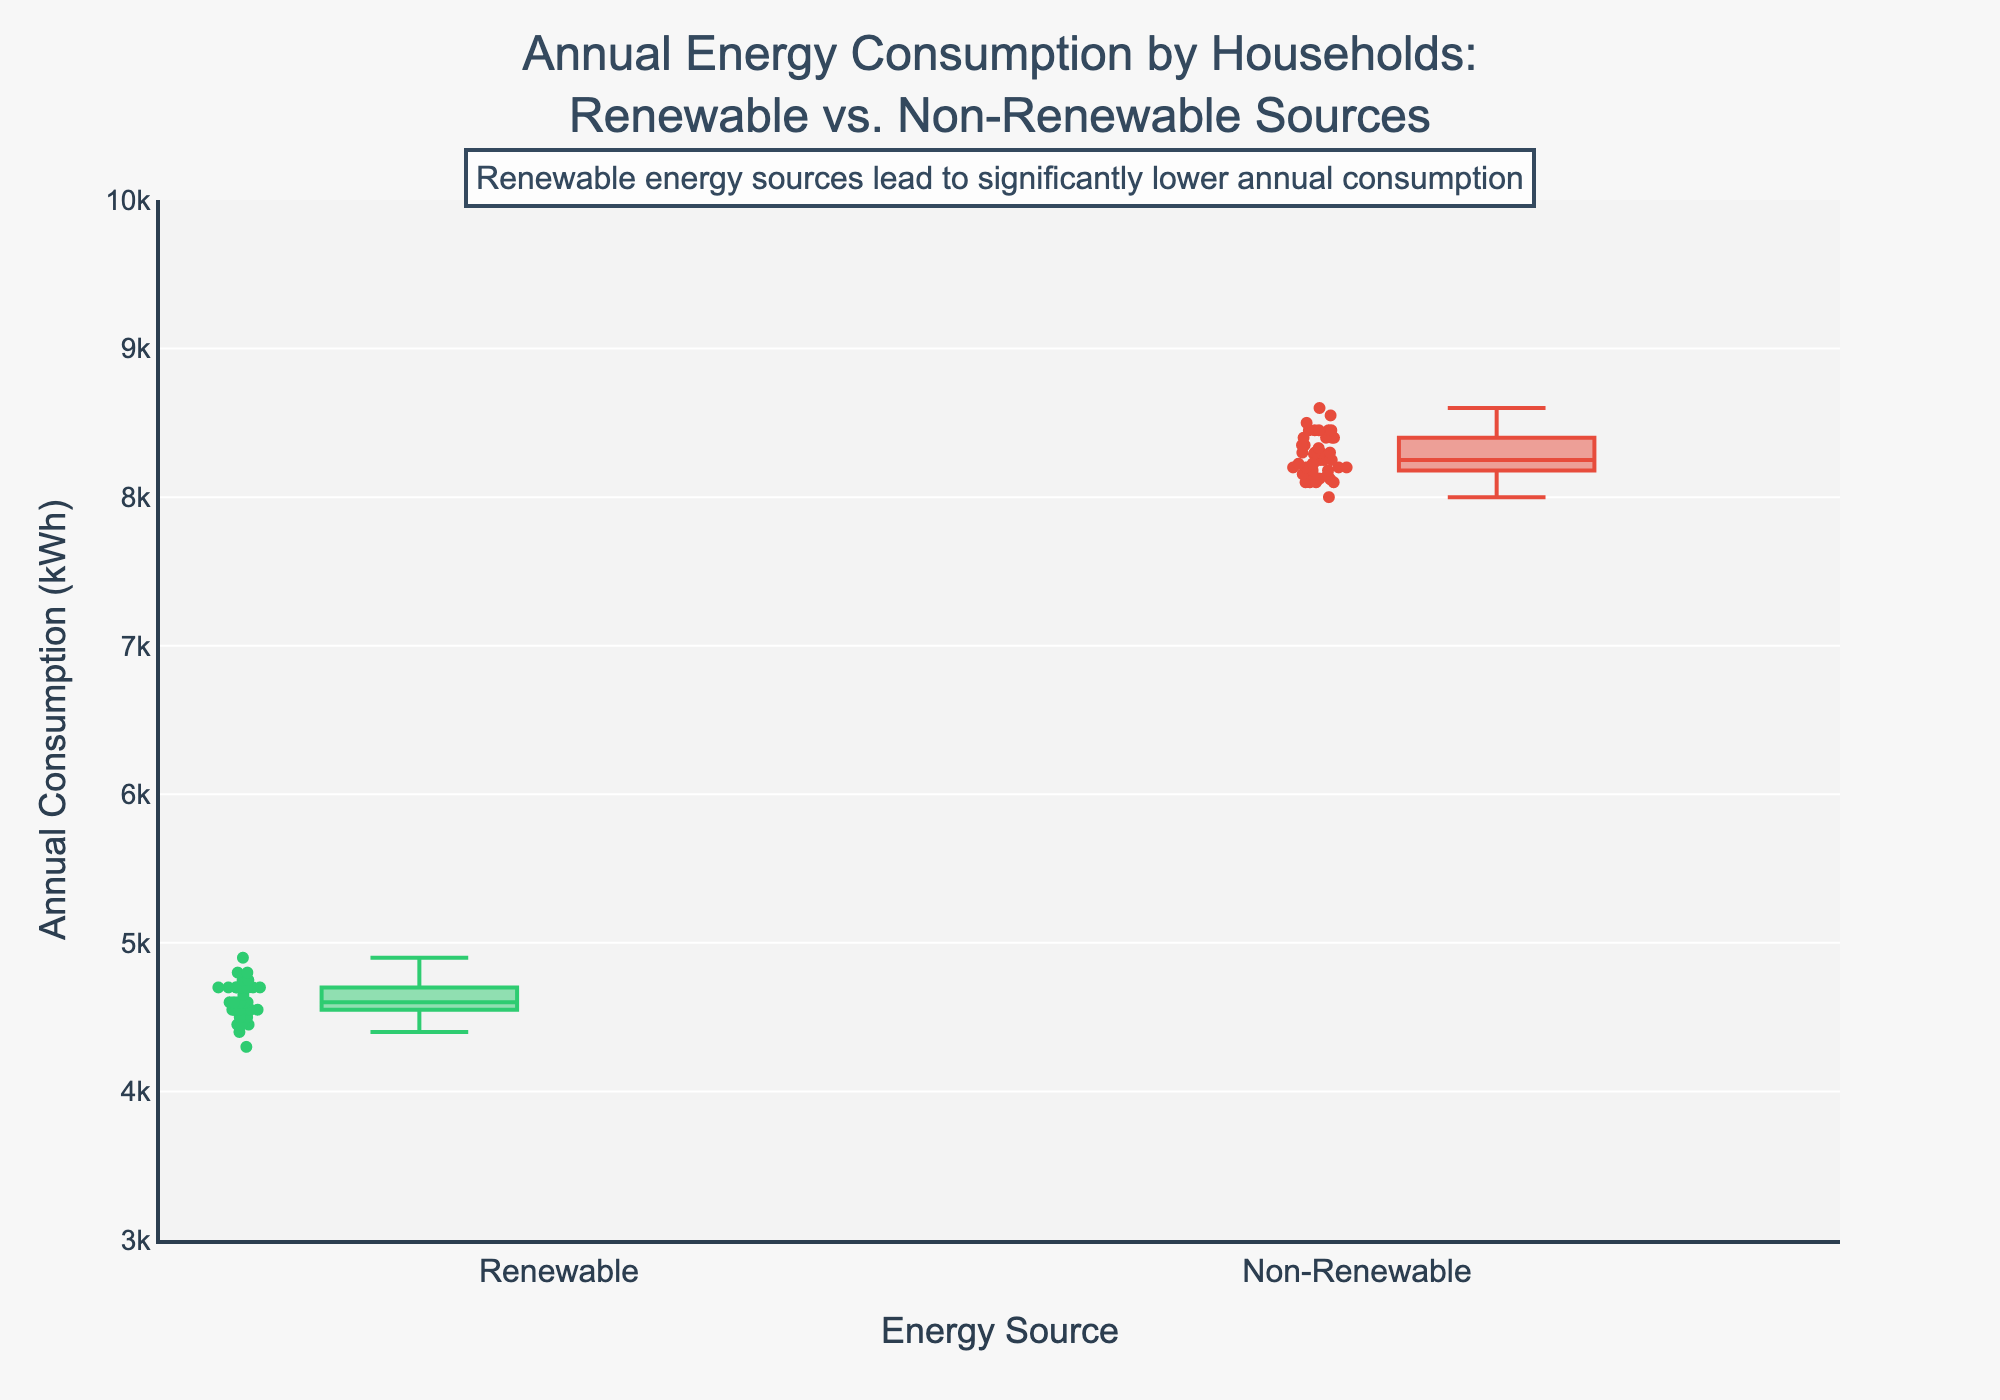What is the title of the figure? The title is prominently displayed at the top center of the figure. It reads "Annual Energy Consumption by Households: Renewable vs. Non-Renewable Sources".
Answer: Annual Energy Consumption by Households: Renewable vs. Non-Renewable Sources What are the colors representing each energy source? The colors used for the different groups are clearly shown in the box plot. Renewable energy sources are represented by green, and non-renewable energy sources are reflected in red.
Answer: Green for renewable and red for non-renewable What is the y-axis title? The y-axis title is placed vertically along the left side of the plot, and it reads "Annual Consumption (kWh)".
Answer: Annual Consumption (kWh) Which group has a higher median annual consumption? The median annual consumption for each group is indicated by the line inside each box. The non-renewable group has a higher median value compared to the renewable group.
Answer: Non-renewable What is the range of the y-axis? The y-axis range can be observed from the axis labels, which go from 3000 to 10000 kWh.
Answer: 3000 to 10000 kWh What is the general trend indicated by the annotation in the figure? The annotation at the top of the plot mentions that renewable energy sources lead to significantly lower annual consumption, suggesting a general trend of higher efficiency or lower usage with renewable sources.
Answer: Renewable energy sources lead to significantly lower annual consumption How does the interquartile range (IQR) of renewable energy compare to non-renewable energy? The IQR is the range between the first quartile (Q1) and the third quartile (Q3) of the data. By examining the height of the boxes in the plot, the IQR for renewable energy is smaller compared to non-renewable energy, indicating less variability.
Answer: Smaller IQR for renewable energy What is the approximate maximum value for the non-renewable energy group? The maximum value of the non-renewable energy group is represented by the upper whisker of the red box plot. This value is around 8600 kWh.
Answer: Around 8600 kWh What can be inferred about the distribution of annual consumption for households using non-renewable energy compared to those using renewable energy? The non-renewable energy group has a higher median and larger IQR, indicating higher and more variable annual consumption. The renewable group has lower median consumption and less variability, as indicated by the shorter whiskers and smaller IQR.
Answer: Higher and more variable consumption for non-renewable users 